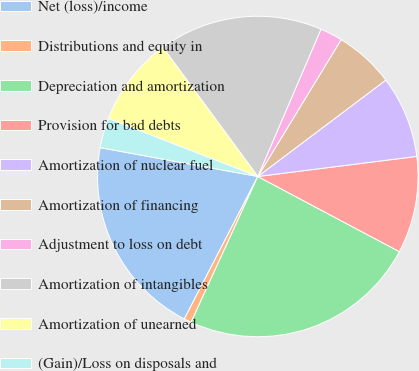<chart> <loc_0><loc_0><loc_500><loc_500><pie_chart><fcel>Net (loss)/income<fcel>Distributions and equity in<fcel>Depreciation and amortization<fcel>Provision for bad debts<fcel>Amortization of nuclear fuel<fcel>Amortization of financing<fcel>Adjustment to loss on debt<fcel>Amortization of intangibles<fcel>Amortization of unearned<fcel>(Gain)/Loss on disposals and<nl><fcel>20.3%<fcel>0.75%<fcel>24.06%<fcel>9.77%<fcel>8.27%<fcel>6.02%<fcel>2.26%<fcel>16.54%<fcel>9.02%<fcel>3.01%<nl></chart> 